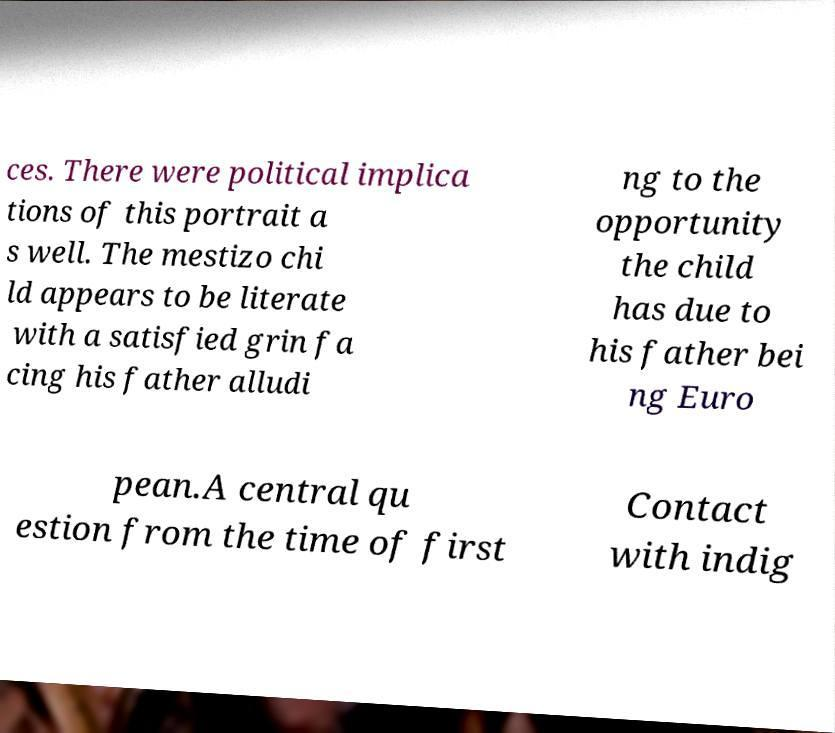What messages or text are displayed in this image? I need them in a readable, typed format. ces. There were political implica tions of this portrait a s well. The mestizo chi ld appears to be literate with a satisfied grin fa cing his father alludi ng to the opportunity the child has due to his father bei ng Euro pean.A central qu estion from the time of first Contact with indig 